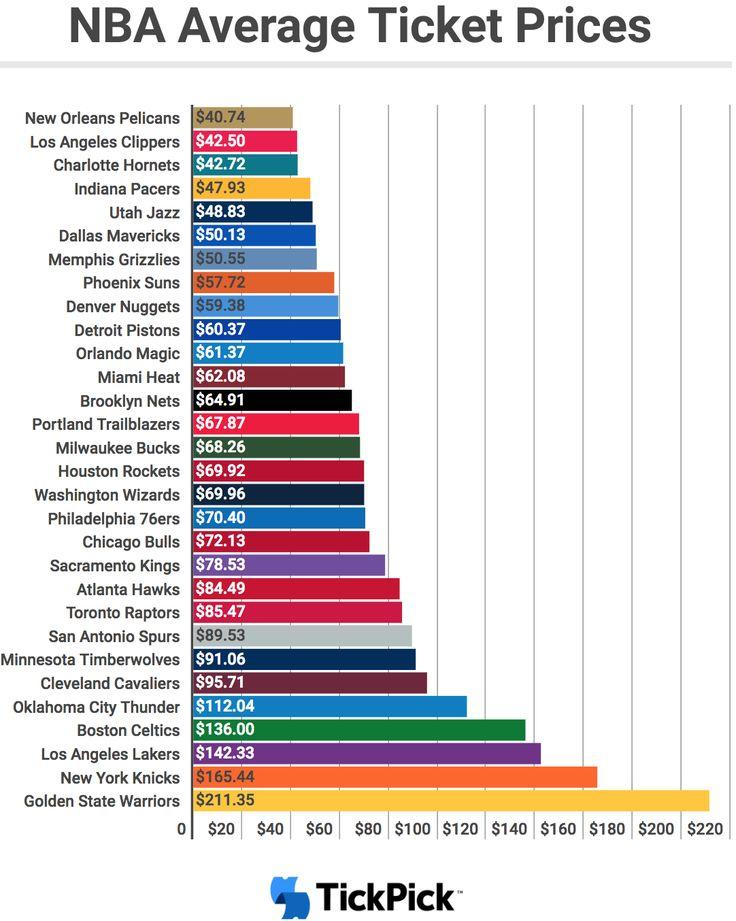Specify some key components in this picture. The total ticket rate for the Detroit Pistons and Orlando Magic is $121.74. The ticket rate of the New York Knicks is significantly higher when compared to the Boston Celtics, with a difference of 29.44. 